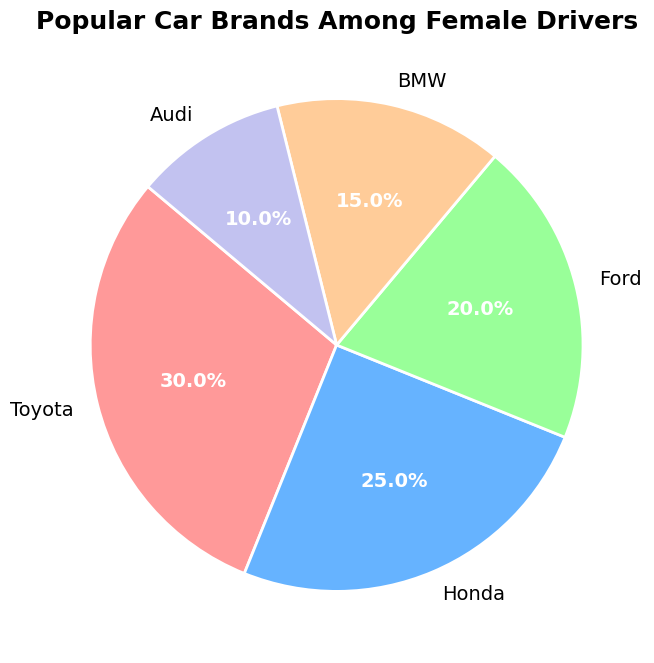What is the most popular car brand among female drivers? The slice labeled 'Toyota' takes up the largest portion of the pie chart. According to the data shown on the pie chart, 30% of female drivers prefer Toyota.
Answer: Toyota What is the combined percentage of female drivers who prefer BMW and Audi? From the pie chart, BMW has a 15% share and Audi has a 10% share. Adding these together gives 15% + 10% = 25%.
Answer: 25% Which brand has a higher percentage of female drivers, Honda or Ford? The pie chart shows that Honda accounts for 25% while Ford accounts for 20% of the preferences. Therefore, Honda has a higher percentage.
Answer: Honda By how much does the percentage of female drivers who prefer Toyota exceed those who prefer Audi? Toyota has 30% and Audi has 10%. The difference is 30% - 10% = 20%.
Answer: 20% What is the range of percentages in the pie chart? The highest percentage is for Toyota at 30%, and the lowest is for Audi at 10%. The range is 30% - 10% = 20%.
Answer: 20% If you were to name the top three car brands preferred by female drivers, which brands would they be? The top three brands are those with the highest percentages: Toyota (30%), Honda (25%), and Ford (20%).
Answer: Toyota, Honda, Ford What is the percentage difference between the second most and the least popular car brands? Honda is the second most popular with 25%, and Audi is the least popular with 10%. The difference is 25% - 10% = 15%.
Answer: 15% Which segments of the pie chart appear in a similar color shade, and what might this signify visually? The pie chart uses different colors for each segment. Visually, there aren't similar shades used, which helps clearly distinguish each brand. This prevents any potential confusion in identifying the slices based on color.
Answer: Different shades 